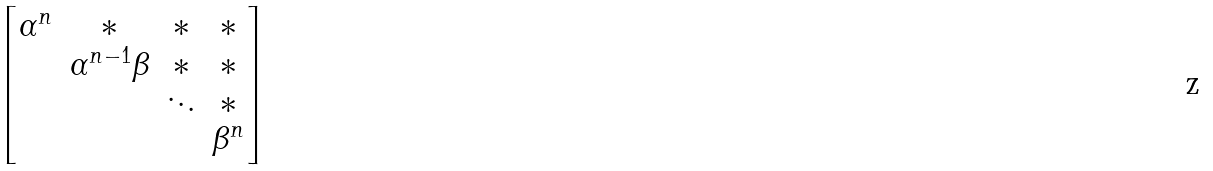<formula> <loc_0><loc_0><loc_500><loc_500>\begin{bmatrix} \alpha ^ { n } & * & * & * \\ & \alpha ^ { n - 1 } \beta & * & * \\ & & \ddots & * \\ & & & \beta ^ { n } \end{bmatrix}</formula> 